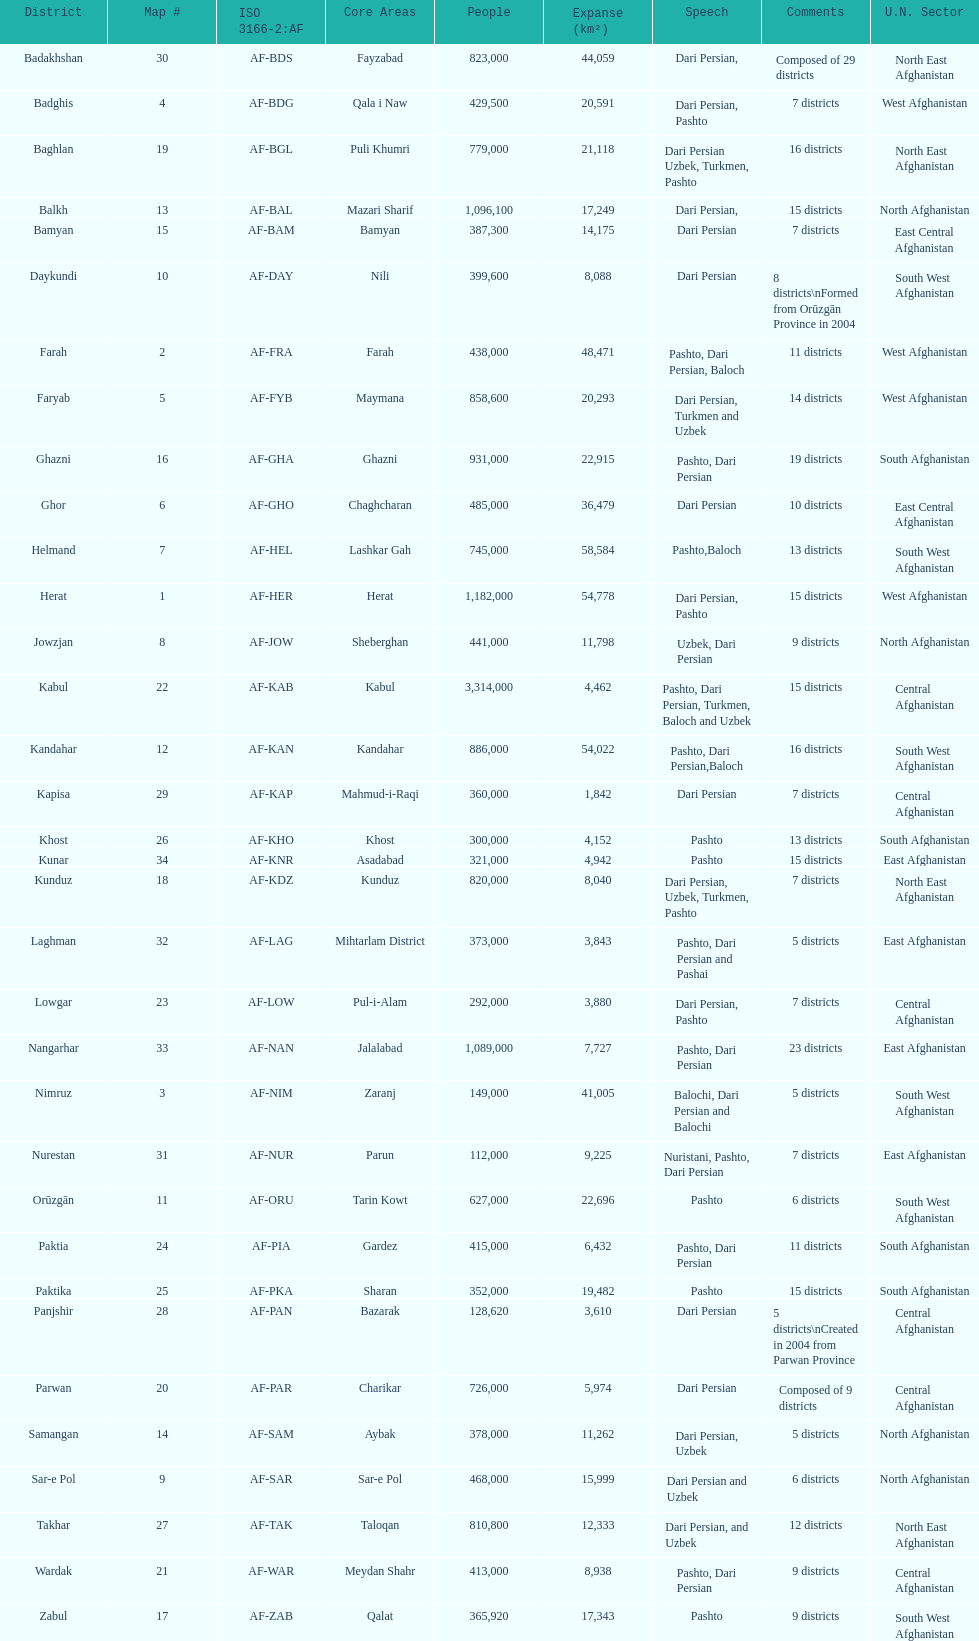How many provinces in afghanistan speak dari persian? 28. 